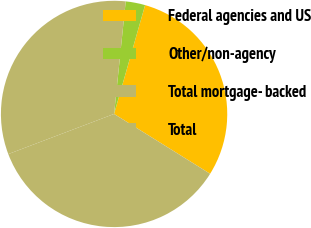Convert chart. <chart><loc_0><loc_0><loc_500><loc_500><pie_chart><fcel>Federal agencies and US<fcel>Other/non-agency<fcel>Total mortgage- backed<fcel>Total<nl><fcel>29.45%<fcel>2.78%<fcel>32.41%<fcel>35.36%<nl></chart> 